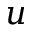<formula> <loc_0><loc_0><loc_500><loc_500>u</formula> 